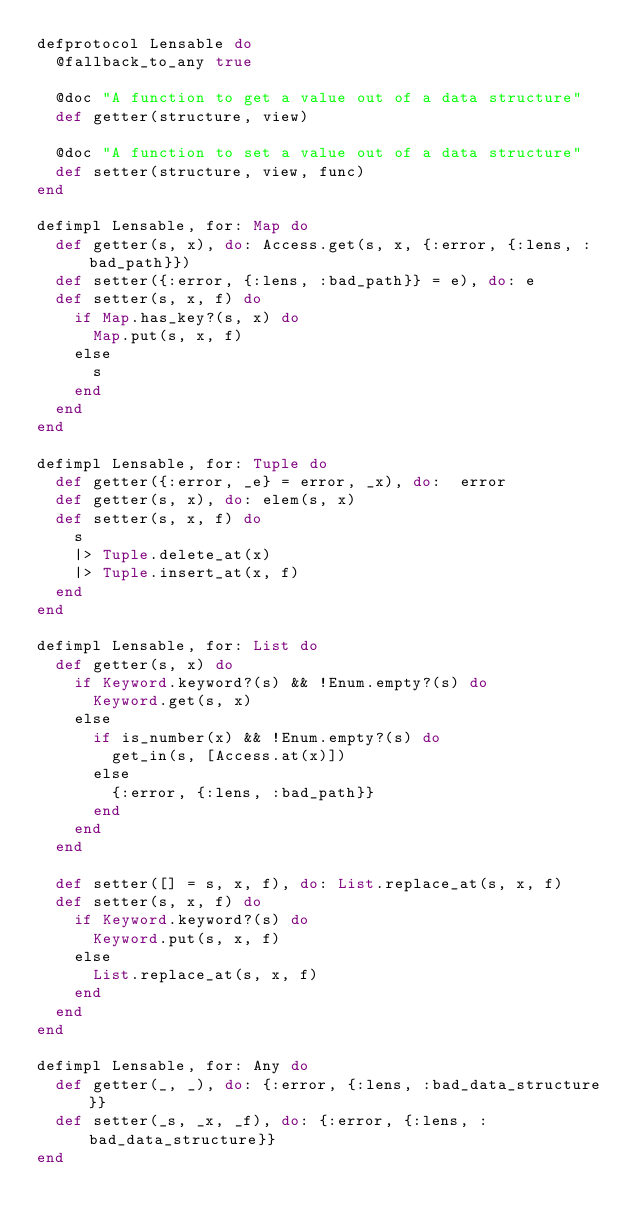<code> <loc_0><loc_0><loc_500><loc_500><_Elixir_>defprotocol Lensable do
  @fallback_to_any true

  @doc "A function to get a value out of a data structure"
  def getter(structure, view)

  @doc "A function to set a value out of a data structure"
  def setter(structure, view, func)
end

defimpl Lensable, for: Map do
  def getter(s, x), do: Access.get(s, x, {:error, {:lens, :bad_path}})
  def setter({:error, {:lens, :bad_path}} = e), do: e
  def setter(s, x, f) do
    if Map.has_key?(s, x) do
      Map.put(s, x, f)
    else
      s
    end
  end
end

defimpl Lensable, for: Tuple do
  def getter({:error, _e} = error, _x), do:  error
  def getter(s, x), do: elem(s, x)
  def setter(s, x, f) do
    s
    |> Tuple.delete_at(x)
    |> Tuple.insert_at(x, f)
  end
end

defimpl Lensable, for: List do
  def getter(s, x) do
    if Keyword.keyword?(s) && !Enum.empty?(s) do
      Keyword.get(s, x)
    else
      if is_number(x) && !Enum.empty?(s) do
        get_in(s, [Access.at(x)])
      else
        {:error, {:lens, :bad_path}}
      end
    end
  end

  def setter([] = s, x, f), do: List.replace_at(s, x, f)
  def setter(s, x, f) do
    if Keyword.keyword?(s) do
      Keyword.put(s, x, f)
    else
      List.replace_at(s, x, f)
    end
  end
end

defimpl Lensable, for: Any do
  def getter(_, _), do: {:error, {:lens, :bad_data_structure}}
  def setter(_s, _x, _f), do: {:error, {:lens, :bad_data_structure}}
end
</code> 